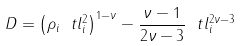<formula> <loc_0><loc_0><loc_500><loc_500>D = \left ( \rho _ { i } \ t l _ { i } ^ { 2 } \right ) ^ { 1 - \nu } - \frac { \nu - 1 } { 2 \nu - 3 } \ t l _ { i } ^ { 2 \nu - 3 }</formula> 